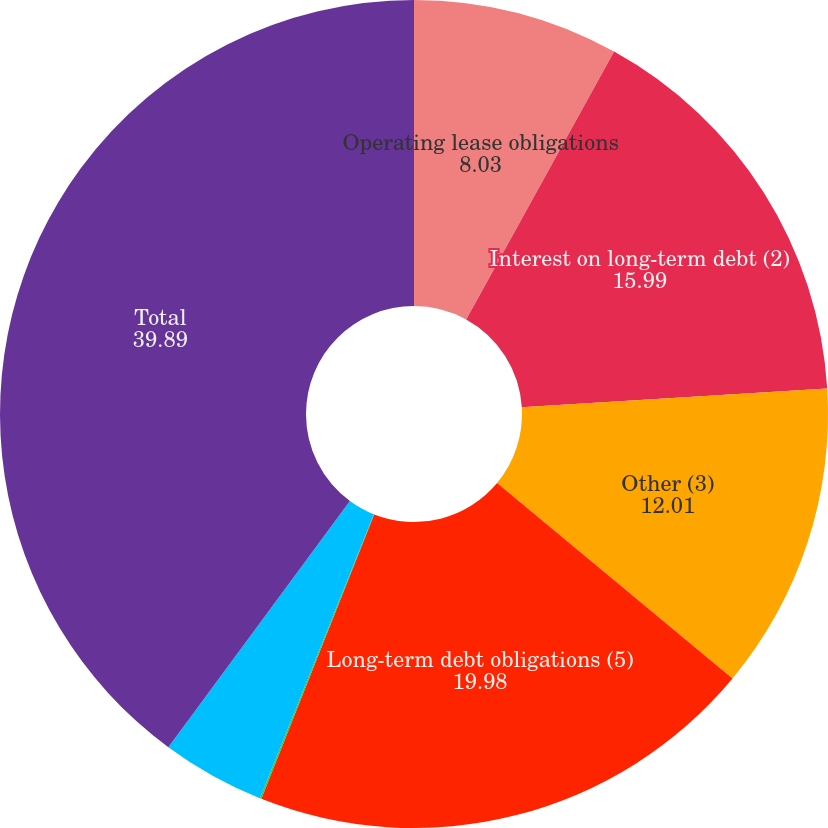Convert chart to OTSL. <chart><loc_0><loc_0><loc_500><loc_500><pie_chart><fcel>Operating lease obligations<fcel>Interest on long-term debt (2)<fcel>Other (3)<fcel>Long-term debt obligations (5)<fcel>Capital lease obligations (6)<fcel>Other (7)<fcel>Total<nl><fcel>8.03%<fcel>15.99%<fcel>12.01%<fcel>19.98%<fcel>0.06%<fcel>4.04%<fcel>39.89%<nl></chart> 